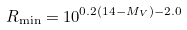<formula> <loc_0><loc_0><loc_500><loc_500>R _ { \min } = 1 0 ^ { 0 . 2 ( 1 4 - M _ { V } ) - 2 . 0 }</formula> 